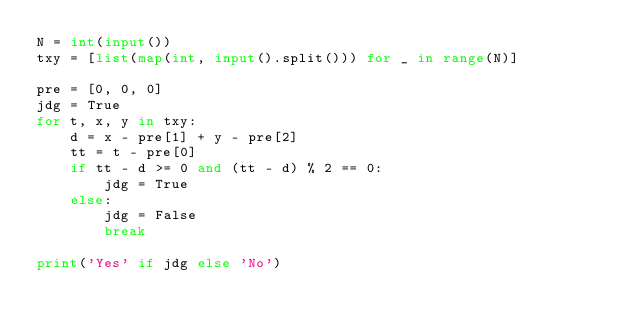Convert code to text. <code><loc_0><loc_0><loc_500><loc_500><_Python_>N = int(input())
txy = [list(map(int, input().split())) for _ in range(N)]

pre = [0, 0, 0]
jdg = True
for t, x, y in txy:
    d = x - pre[1] + y - pre[2]
    tt = t - pre[0]
    if tt - d >= 0 and (tt - d) % 2 == 0:
        jdg = True
    else:
        jdg = False
        break
        
print('Yes' if jdg else 'No')</code> 